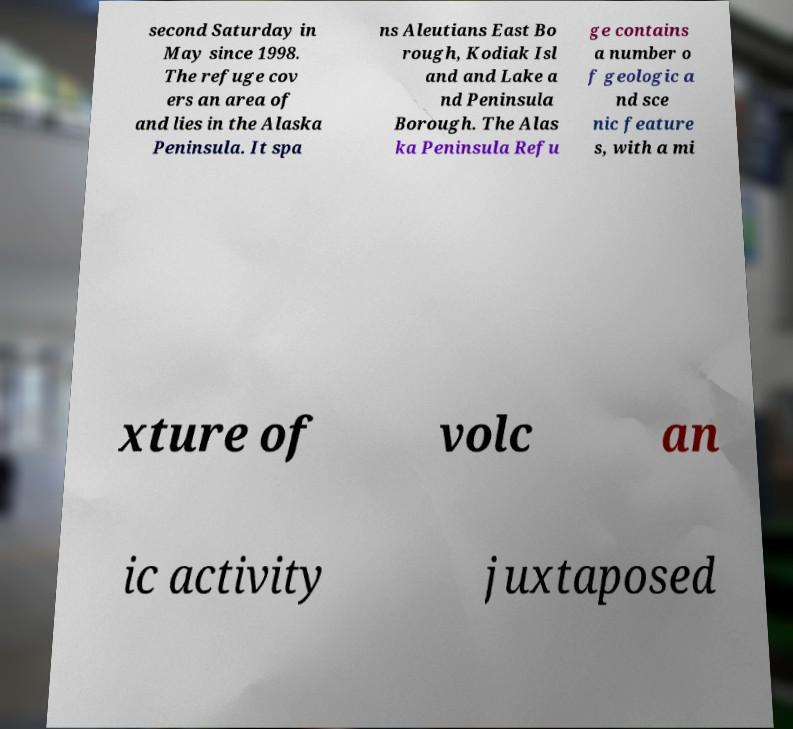I need the written content from this picture converted into text. Can you do that? second Saturday in May since 1998. The refuge cov ers an area of and lies in the Alaska Peninsula. It spa ns Aleutians East Bo rough, Kodiak Isl and and Lake a nd Peninsula Borough. The Alas ka Peninsula Refu ge contains a number o f geologic a nd sce nic feature s, with a mi xture of volc an ic activity juxtaposed 